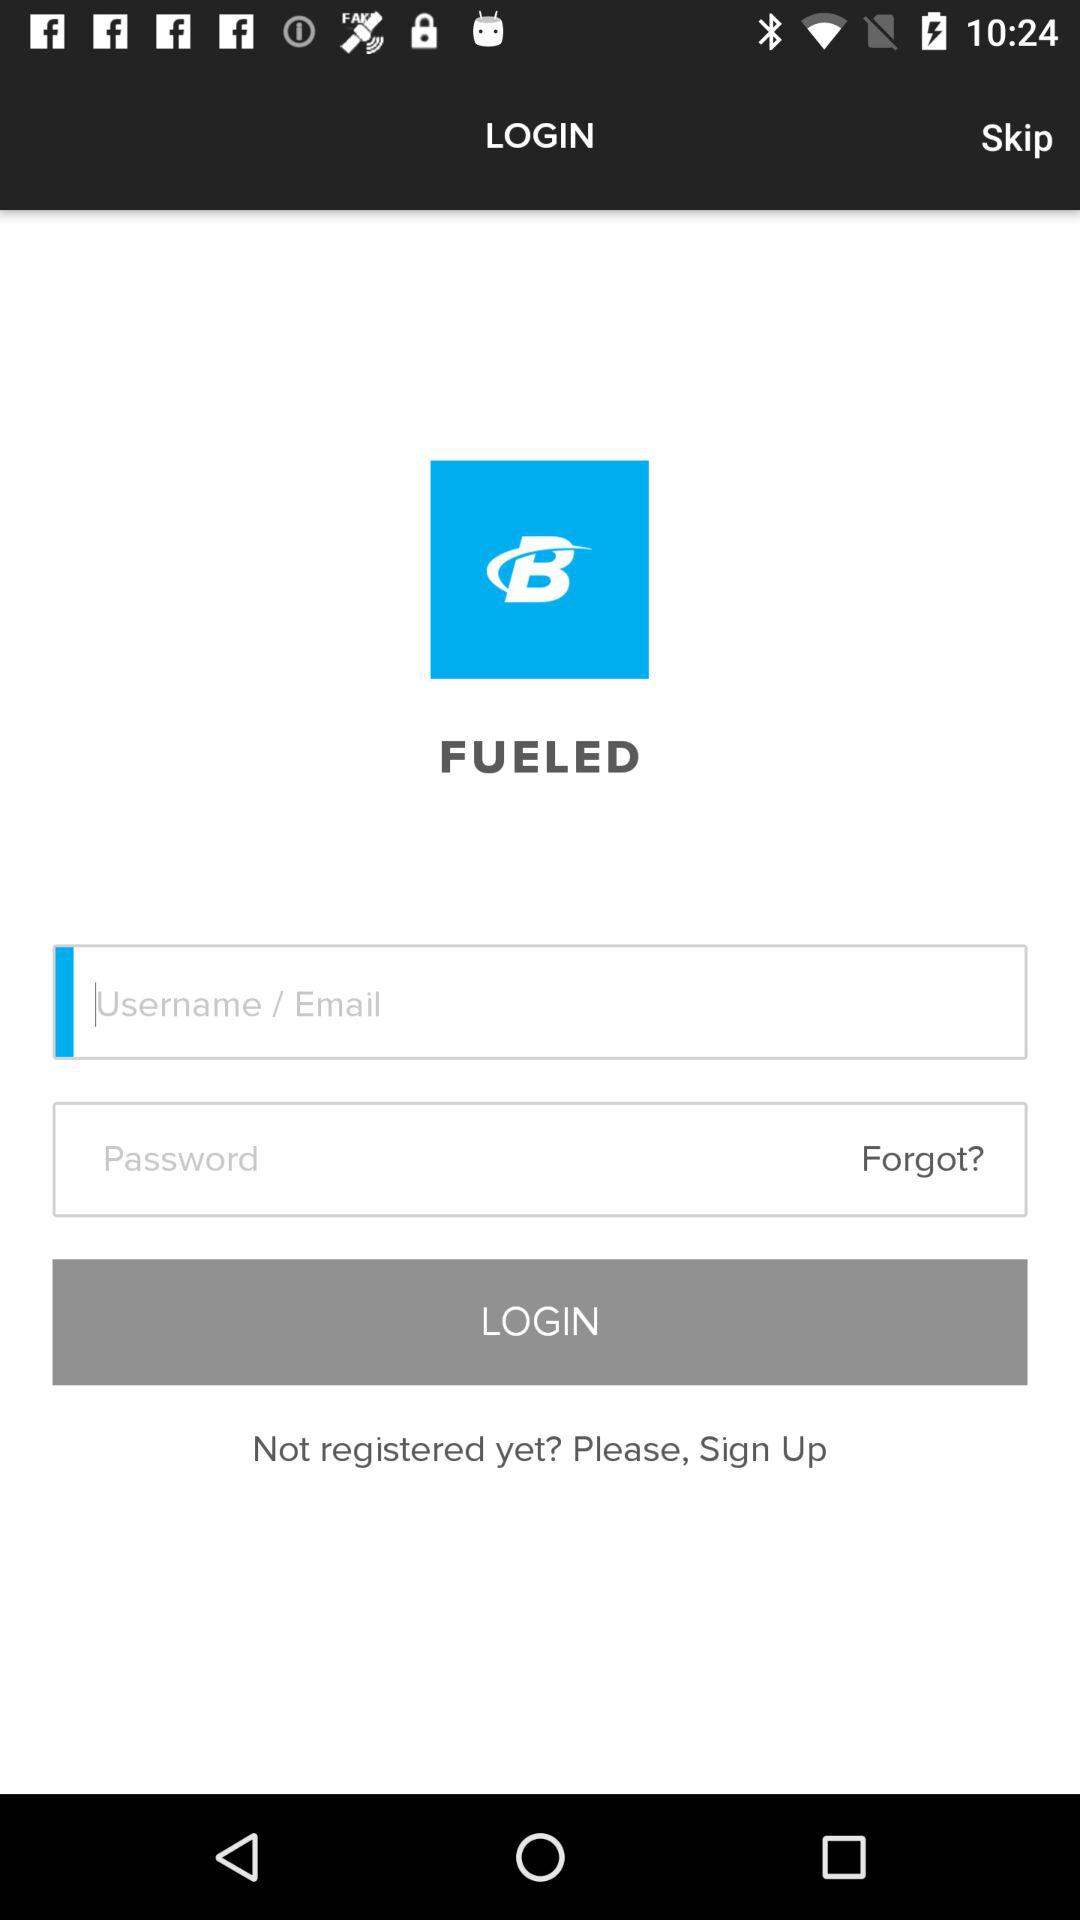How many characters are required for the password?
When the provided information is insufficient, respond with <no answer>. <no answer> 